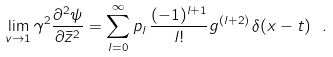Convert formula to latex. <formula><loc_0><loc_0><loc_500><loc_500>\lim _ { v \rightarrow 1 } \gamma ^ { 2 } \frac { \partial ^ { 2 } \psi } { \partial \bar { z } ^ { 2 } } = \sum _ { l = 0 } ^ { \infty } p _ { l } \, \frac { ( - 1 ) ^ { l + 1 } } { l ! } g ^ { ( l + 2 ) } \, \delta ( x - t ) \ .</formula> 